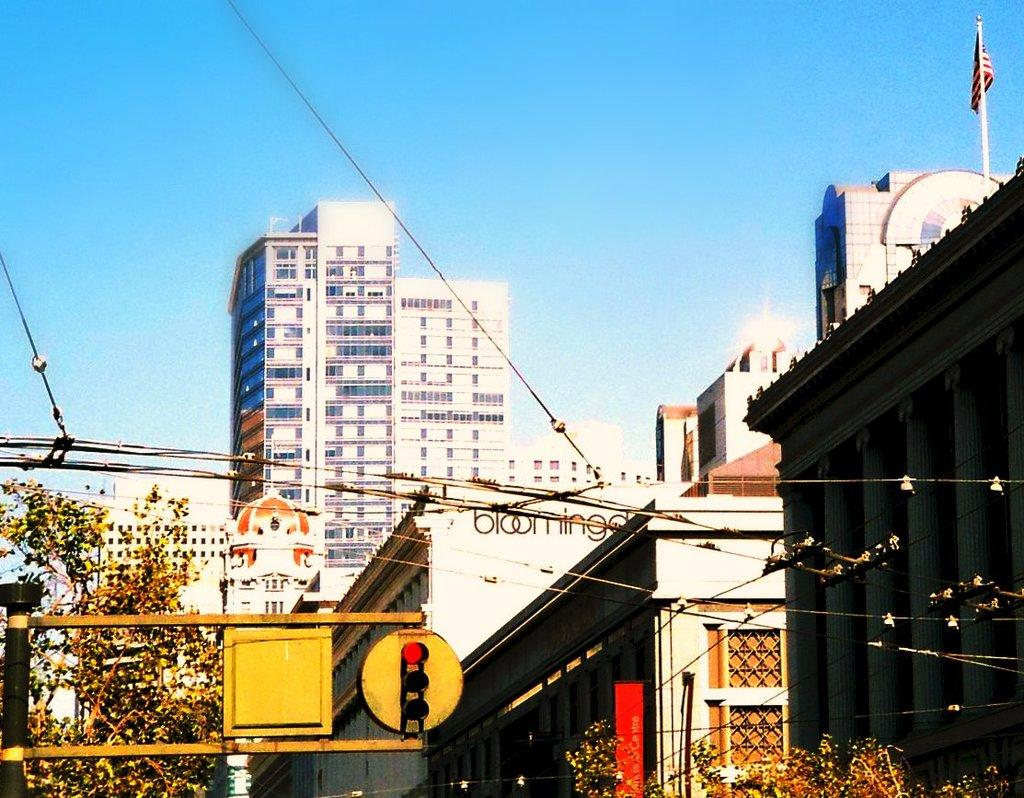What type of natural elements can be seen in the image? There are trees in the image. What type of man-made structures are present in the image? There are buildings in the image. What type of symbols or markers are visible in the image? There are flags and traffic lights in the image. What type of infrastructure is present in the image? There are electrical cables in the image. What type of decorations or advertisements are present on the buildings? There are banners on the buildings in the image. What type of notebook is visible on the electrical cables in the image? There is no notebook present on the electrical cables in the image. What type of button can be seen on the traffic lights in the image? There is no button present on the traffic lights in the image. 